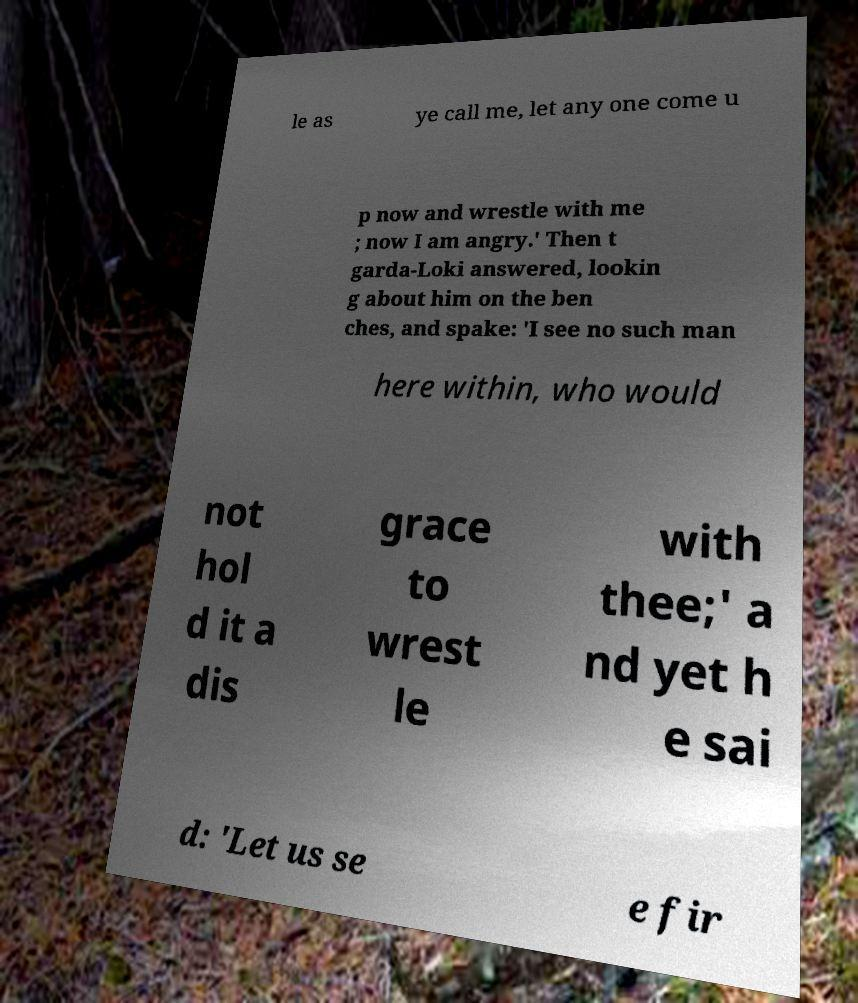I need the written content from this picture converted into text. Can you do that? le as ye call me, let any one come u p now and wrestle with me ; now I am angry.' Then t garda-Loki answered, lookin g about him on the ben ches, and spake: 'I see no such man here within, who would not hol d it a dis grace to wrest le with thee;' a nd yet h e sai d: 'Let us se e fir 